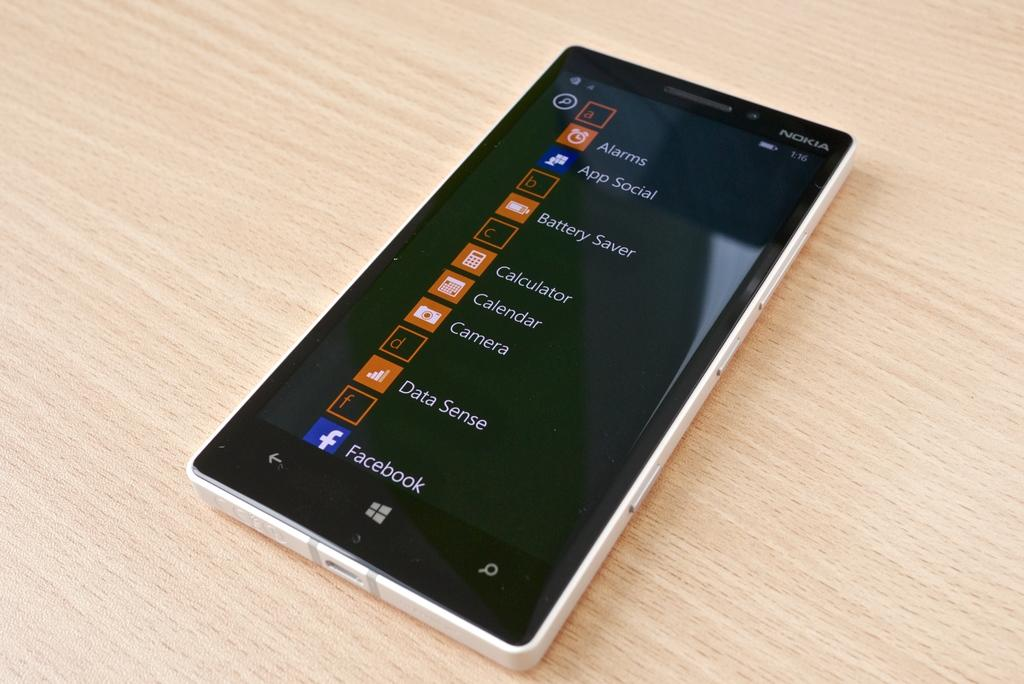<image>
Give a short and clear explanation of the subsequent image. A Windows smartphone made by Nokia displaying a column of Apps. 